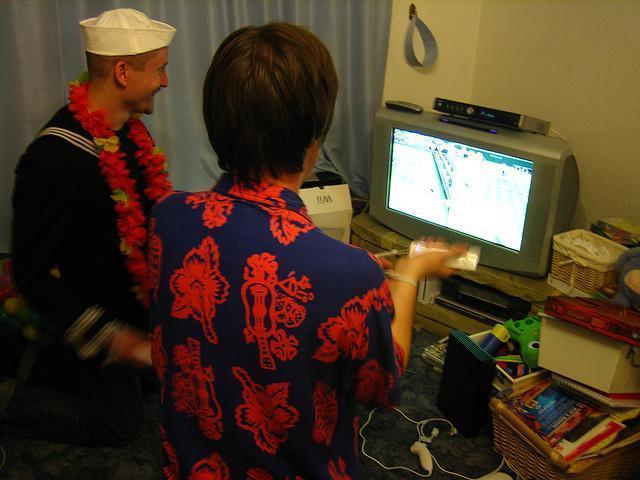How many people are looking at the computer?
Give a very brief answer. 2. How many color on her shirt?
Give a very brief answer. 2. How many people are visible?
Give a very brief answer. 2. How many books are there?
Give a very brief answer. 2. How many leather couches are there in the living room?
Give a very brief answer. 0. 